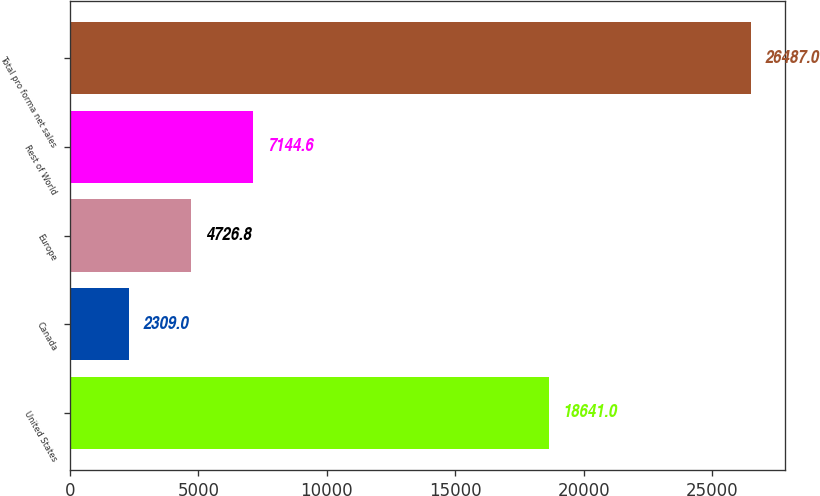Convert chart to OTSL. <chart><loc_0><loc_0><loc_500><loc_500><bar_chart><fcel>United States<fcel>Canada<fcel>Europe<fcel>Rest of World<fcel>Total pro forma net sales<nl><fcel>18641<fcel>2309<fcel>4726.8<fcel>7144.6<fcel>26487<nl></chart> 